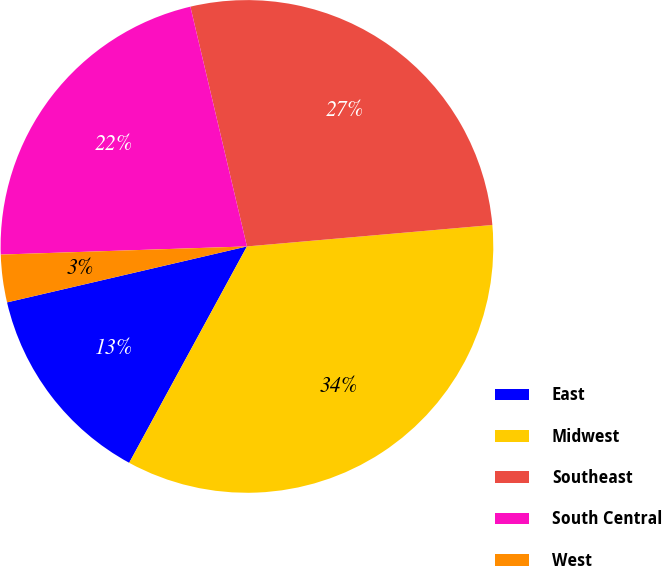<chart> <loc_0><loc_0><loc_500><loc_500><pie_chart><fcel>East<fcel>Midwest<fcel>Southeast<fcel>South Central<fcel>West<nl><fcel>13.42%<fcel>34.32%<fcel>27.3%<fcel>21.84%<fcel>3.12%<nl></chart> 